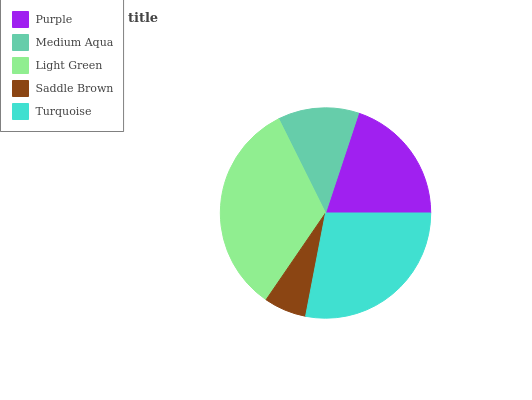Is Saddle Brown the minimum?
Answer yes or no. Yes. Is Light Green the maximum?
Answer yes or no. Yes. Is Medium Aqua the minimum?
Answer yes or no. No. Is Medium Aqua the maximum?
Answer yes or no. No. Is Purple greater than Medium Aqua?
Answer yes or no. Yes. Is Medium Aqua less than Purple?
Answer yes or no. Yes. Is Medium Aqua greater than Purple?
Answer yes or no. No. Is Purple less than Medium Aqua?
Answer yes or no. No. Is Purple the high median?
Answer yes or no. Yes. Is Purple the low median?
Answer yes or no. Yes. Is Saddle Brown the high median?
Answer yes or no. No. Is Light Green the low median?
Answer yes or no. No. 